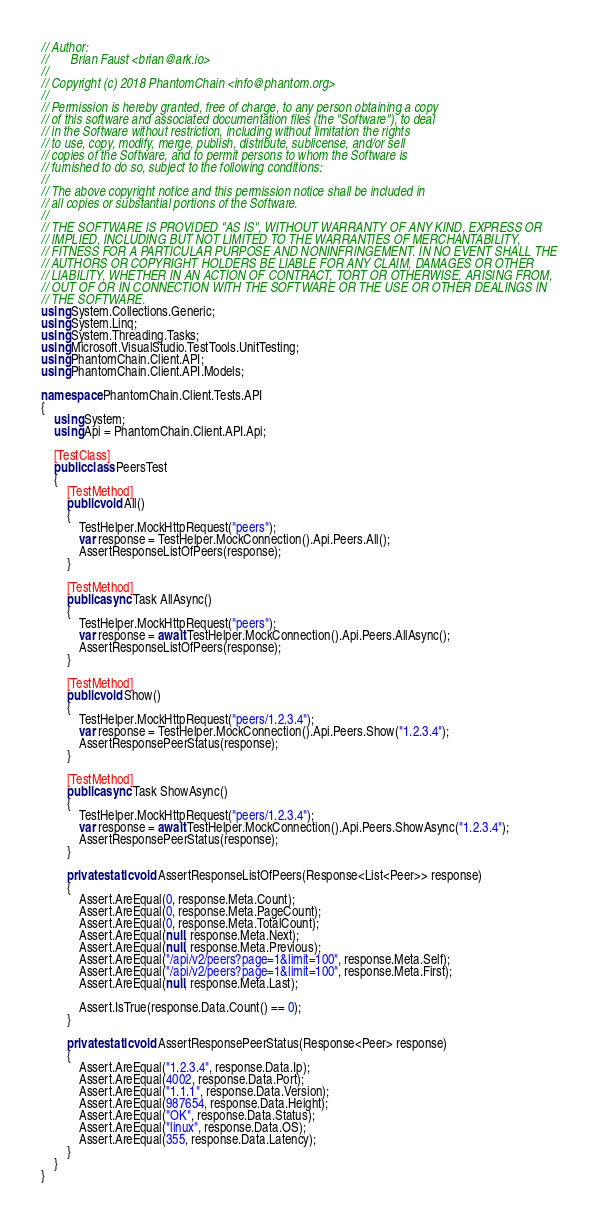Convert code to text. <code><loc_0><loc_0><loc_500><loc_500><_C#_>// Author:
//       Brian Faust <brian@ark.io>
//
// Copyright (c) 2018 PhantomChain <info@phantom.org>
//
// Permission is hereby granted, free of charge, to any person obtaining a copy
// of this software and associated documentation files (the "Software"), to deal
// in the Software without restriction, including without limitation the rights
// to use, copy, modify, merge, publish, distribute, sublicense, and/or sell
// copies of the Software, and to permit persons to whom the Software is
// furnished to do so, subject to the following conditions:
//
// The above copyright notice and this permission notice shall be included in
// all copies or substantial portions of the Software.
//
// THE SOFTWARE IS PROVIDED "AS IS", WITHOUT WARRANTY OF ANY KIND, EXPRESS OR
// IMPLIED, INCLUDING BUT NOT LIMITED TO THE WARRANTIES OF MERCHANTABILITY,
// FITNESS FOR A PARTICULAR PURPOSE AND NONINFRINGEMENT. IN NO EVENT SHALL THE
// AUTHORS OR COPYRIGHT HOLDERS BE LIABLE FOR ANY CLAIM, DAMAGES OR OTHER
// LIABILITY, WHETHER IN AN ACTION OF CONTRACT, TORT OR OTHERWISE, ARISING FROM,
// OUT OF OR IN CONNECTION WITH THE SOFTWARE OR THE USE OR OTHER DEALINGS IN
// THE SOFTWARE.
using System.Collections.Generic;
using System.Linq;
using System.Threading.Tasks;
using Microsoft.VisualStudio.TestTools.UnitTesting;
using PhantomChain.Client.API;
using PhantomChain.Client.API.Models;

namespace PhantomChain.Client.Tests.API
{
    using System;
    using Api = PhantomChain.Client.API.Api;

    [TestClass]
    public class PeersTest
    {
        [TestMethod]
        public void All()
        {
            TestHelper.MockHttpRequest("peers");
            var response = TestHelper.MockConnection().Api.Peers.All();
            AssertResponseListOfPeers(response);
        }

        [TestMethod]
        public async Task AllAsync()
        {
            TestHelper.MockHttpRequest("peers");
            var response = await TestHelper.MockConnection().Api.Peers.AllAsync();
            AssertResponseListOfPeers(response);
        }

        [TestMethod]
        public void Show()
        {
            TestHelper.MockHttpRequest("peers/1.2.3.4");
            var response = TestHelper.MockConnection().Api.Peers.Show("1.2.3.4");
            AssertResponsePeerStatus(response);
        }

        [TestMethod]
        public async Task ShowAsync()
        {
            TestHelper.MockHttpRequest("peers/1.2.3.4");
            var response = await TestHelper.MockConnection().Api.Peers.ShowAsync("1.2.3.4");
            AssertResponsePeerStatus(response);
        }

        private static void AssertResponseListOfPeers(Response<List<Peer>> response)
        {
            Assert.AreEqual(0, response.Meta.Count);
            Assert.AreEqual(0, response.Meta.PageCount);
            Assert.AreEqual(0, response.Meta.TotalCount);
            Assert.AreEqual(null, response.Meta.Next);
            Assert.AreEqual(null, response.Meta.Previous);
            Assert.AreEqual("/api/v2/peers?page=1&limit=100", response.Meta.Self);
            Assert.AreEqual("/api/v2/peers?page=1&limit=100", response.Meta.First);
            Assert.AreEqual(null, response.Meta.Last);

            Assert.IsTrue(response.Data.Count() == 0);
        }

        private static void AssertResponsePeerStatus(Response<Peer> response)
        {
            Assert.AreEqual("1.2.3.4", response.Data.Ip);
            Assert.AreEqual(4002, response.Data.Port);
            Assert.AreEqual("1.1.1", response.Data.Version);
            Assert.AreEqual(987654, response.Data.Height);
            Assert.AreEqual("OK", response.Data.Status);
            Assert.AreEqual("linux", response.Data.OS);
            Assert.AreEqual(355, response.Data.Latency);
        }
    }
}
</code> 